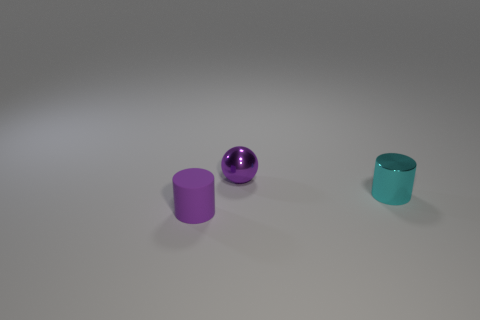What size is the object that is in front of the cyan metallic cylinder?
Make the answer very short. Small. How many things have the same size as the metallic cylinder?
Your answer should be compact. 2. Do the matte cylinder and the purple thing behind the small metal cylinder have the same size?
Offer a terse response. Yes. What number of things are tiny cyan cylinders or small brown blocks?
Your answer should be very brief. 1. How many tiny shiny things have the same color as the ball?
Make the answer very short. 0. What is the shape of the purple thing that is the same size as the purple cylinder?
Keep it short and to the point. Sphere. Are there any other brown objects that have the same shape as the rubber object?
Make the answer very short. No. What number of purple spheres are the same material as the tiny cyan cylinder?
Give a very brief answer. 1. Is the small thing that is in front of the cyan cylinder made of the same material as the sphere?
Your response must be concise. No. Are there more purple cylinders in front of the tiny purple cylinder than purple rubber things behind the small cyan shiny cylinder?
Your response must be concise. No. 